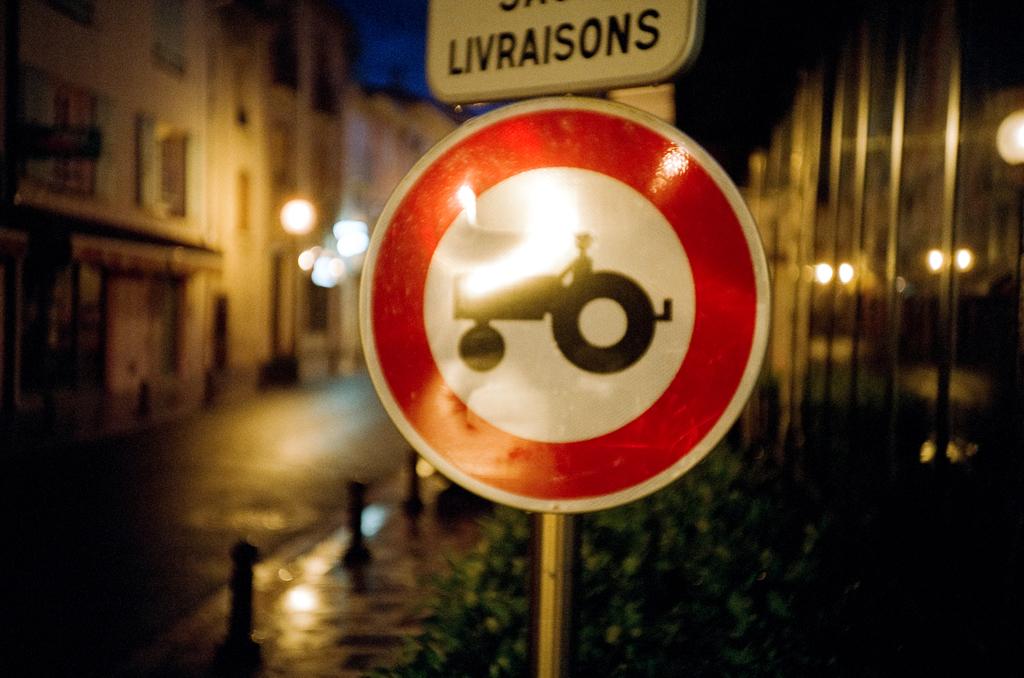What does this sign say is on the road?
Provide a succinct answer. Answering does not require reading text in the image. 